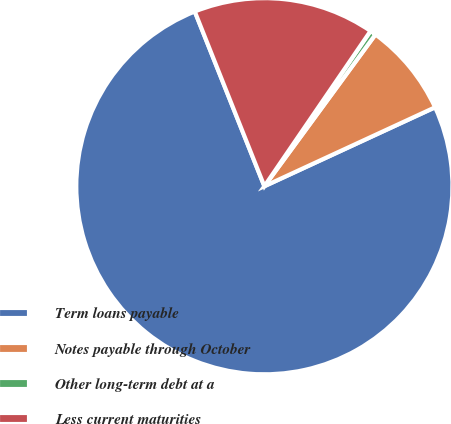Convert chart to OTSL. <chart><loc_0><loc_0><loc_500><loc_500><pie_chart><fcel>Term loans payable<fcel>Notes payable through October<fcel>Other long-term debt at a<fcel>Less current maturities<nl><fcel>75.86%<fcel>8.05%<fcel>0.51%<fcel>15.58%<nl></chart> 